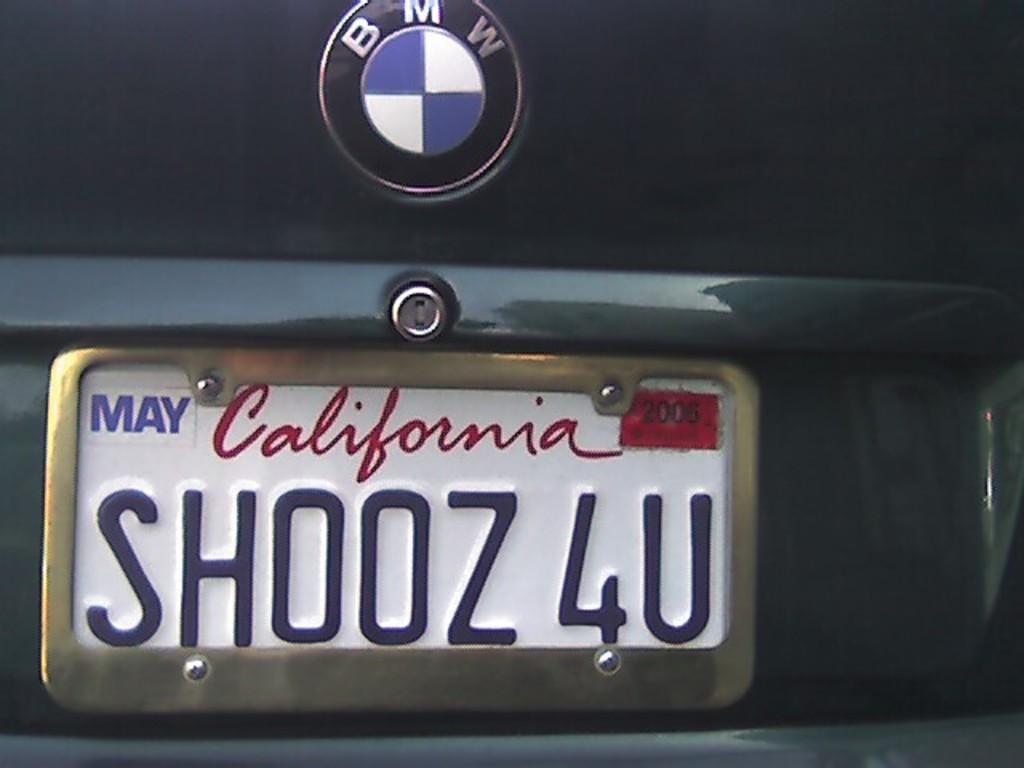<image>
Describe the image concisely. a california license plate on the back of a car 